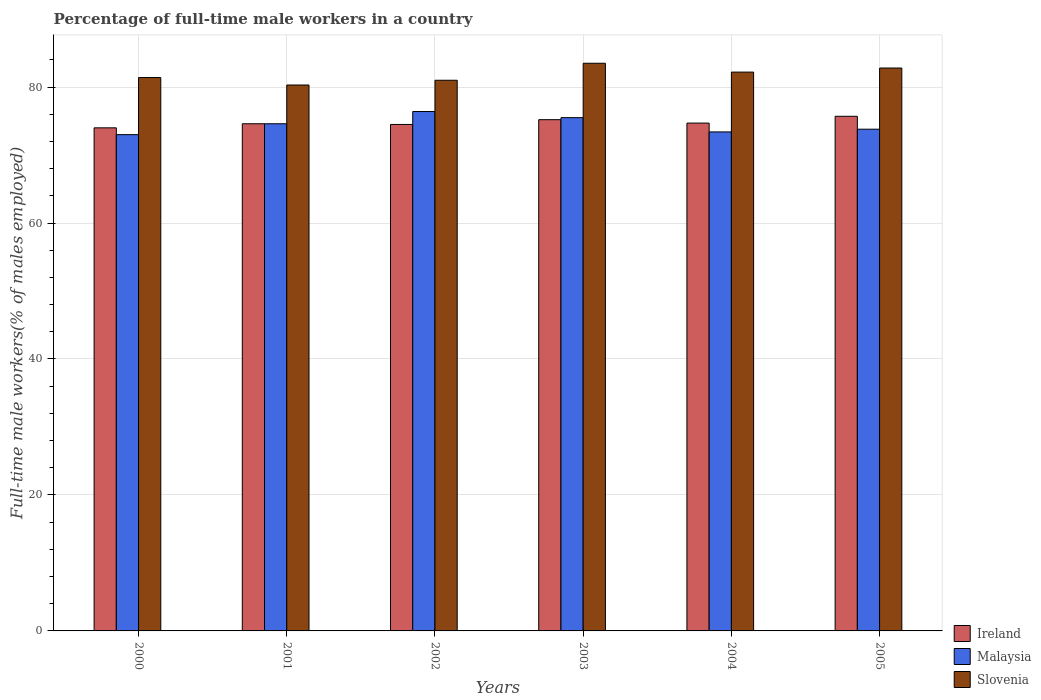How many different coloured bars are there?
Provide a short and direct response. 3. Are the number of bars per tick equal to the number of legend labels?
Your answer should be very brief. Yes. Are the number of bars on each tick of the X-axis equal?
Give a very brief answer. Yes. How many bars are there on the 3rd tick from the right?
Provide a succinct answer. 3. What is the percentage of full-time male workers in Malaysia in 2003?
Offer a very short reply. 75.5. Across all years, what is the maximum percentage of full-time male workers in Slovenia?
Provide a short and direct response. 83.5. In which year was the percentage of full-time male workers in Ireland minimum?
Provide a short and direct response. 2000. What is the total percentage of full-time male workers in Malaysia in the graph?
Your response must be concise. 446.7. What is the difference between the percentage of full-time male workers in Malaysia in 2002 and that in 2004?
Your response must be concise. 3. What is the difference between the percentage of full-time male workers in Ireland in 2001 and the percentage of full-time male workers in Slovenia in 2004?
Provide a short and direct response. -7.6. What is the average percentage of full-time male workers in Ireland per year?
Offer a terse response. 74.78. In the year 2002, what is the difference between the percentage of full-time male workers in Malaysia and percentage of full-time male workers in Slovenia?
Your answer should be very brief. -4.6. What is the ratio of the percentage of full-time male workers in Ireland in 2002 to that in 2004?
Ensure brevity in your answer.  1. What is the difference between the highest and the second highest percentage of full-time male workers in Malaysia?
Offer a terse response. 0.9. What is the difference between the highest and the lowest percentage of full-time male workers in Slovenia?
Offer a very short reply. 3.2. In how many years, is the percentage of full-time male workers in Ireland greater than the average percentage of full-time male workers in Ireland taken over all years?
Provide a short and direct response. 2. What does the 2nd bar from the left in 2001 represents?
Provide a succinct answer. Malaysia. What does the 2nd bar from the right in 2002 represents?
Your response must be concise. Malaysia. Is it the case that in every year, the sum of the percentage of full-time male workers in Ireland and percentage of full-time male workers in Slovenia is greater than the percentage of full-time male workers in Malaysia?
Your response must be concise. Yes. How many bars are there?
Offer a very short reply. 18. Are all the bars in the graph horizontal?
Your response must be concise. No. How many years are there in the graph?
Provide a short and direct response. 6. What is the difference between two consecutive major ticks on the Y-axis?
Keep it short and to the point. 20. Does the graph contain any zero values?
Keep it short and to the point. No. Does the graph contain grids?
Make the answer very short. Yes. How are the legend labels stacked?
Provide a succinct answer. Vertical. What is the title of the graph?
Ensure brevity in your answer.  Percentage of full-time male workers in a country. Does "Germany" appear as one of the legend labels in the graph?
Provide a short and direct response. No. What is the label or title of the Y-axis?
Offer a very short reply. Full-time male workers(% of males employed). What is the Full-time male workers(% of males employed) of Ireland in 2000?
Give a very brief answer. 74. What is the Full-time male workers(% of males employed) in Slovenia in 2000?
Provide a short and direct response. 81.4. What is the Full-time male workers(% of males employed) of Ireland in 2001?
Your answer should be very brief. 74.6. What is the Full-time male workers(% of males employed) of Malaysia in 2001?
Give a very brief answer. 74.6. What is the Full-time male workers(% of males employed) in Slovenia in 2001?
Your response must be concise. 80.3. What is the Full-time male workers(% of males employed) in Ireland in 2002?
Your answer should be very brief. 74.5. What is the Full-time male workers(% of males employed) in Malaysia in 2002?
Give a very brief answer. 76.4. What is the Full-time male workers(% of males employed) of Ireland in 2003?
Offer a terse response. 75.2. What is the Full-time male workers(% of males employed) of Malaysia in 2003?
Provide a short and direct response. 75.5. What is the Full-time male workers(% of males employed) in Slovenia in 2003?
Offer a very short reply. 83.5. What is the Full-time male workers(% of males employed) of Ireland in 2004?
Give a very brief answer. 74.7. What is the Full-time male workers(% of males employed) in Malaysia in 2004?
Your response must be concise. 73.4. What is the Full-time male workers(% of males employed) in Slovenia in 2004?
Provide a short and direct response. 82.2. What is the Full-time male workers(% of males employed) of Ireland in 2005?
Keep it short and to the point. 75.7. What is the Full-time male workers(% of males employed) in Malaysia in 2005?
Offer a very short reply. 73.8. What is the Full-time male workers(% of males employed) of Slovenia in 2005?
Your answer should be very brief. 82.8. Across all years, what is the maximum Full-time male workers(% of males employed) of Ireland?
Your answer should be very brief. 75.7. Across all years, what is the maximum Full-time male workers(% of males employed) in Malaysia?
Offer a terse response. 76.4. Across all years, what is the maximum Full-time male workers(% of males employed) of Slovenia?
Offer a terse response. 83.5. Across all years, what is the minimum Full-time male workers(% of males employed) of Slovenia?
Offer a very short reply. 80.3. What is the total Full-time male workers(% of males employed) in Ireland in the graph?
Keep it short and to the point. 448.7. What is the total Full-time male workers(% of males employed) in Malaysia in the graph?
Your answer should be very brief. 446.7. What is the total Full-time male workers(% of males employed) in Slovenia in the graph?
Make the answer very short. 491.2. What is the difference between the Full-time male workers(% of males employed) in Ireland in 2000 and that in 2002?
Keep it short and to the point. -0.5. What is the difference between the Full-time male workers(% of males employed) in Slovenia in 2000 and that in 2002?
Your answer should be compact. 0.4. What is the difference between the Full-time male workers(% of males employed) in Ireland in 2000 and that in 2003?
Give a very brief answer. -1.2. What is the difference between the Full-time male workers(% of males employed) in Malaysia in 2000 and that in 2003?
Provide a short and direct response. -2.5. What is the difference between the Full-time male workers(% of males employed) of Slovenia in 2000 and that in 2003?
Your answer should be very brief. -2.1. What is the difference between the Full-time male workers(% of males employed) of Slovenia in 2000 and that in 2004?
Your response must be concise. -0.8. What is the difference between the Full-time male workers(% of males employed) in Slovenia in 2000 and that in 2005?
Offer a terse response. -1.4. What is the difference between the Full-time male workers(% of males employed) of Ireland in 2001 and that in 2002?
Your answer should be very brief. 0.1. What is the difference between the Full-time male workers(% of males employed) in Malaysia in 2001 and that in 2003?
Your answer should be very brief. -0.9. What is the difference between the Full-time male workers(% of males employed) in Slovenia in 2001 and that in 2003?
Offer a terse response. -3.2. What is the difference between the Full-time male workers(% of males employed) of Ireland in 2001 and that in 2004?
Make the answer very short. -0.1. What is the difference between the Full-time male workers(% of males employed) in Malaysia in 2001 and that in 2004?
Offer a terse response. 1.2. What is the difference between the Full-time male workers(% of males employed) in Slovenia in 2001 and that in 2004?
Offer a terse response. -1.9. What is the difference between the Full-time male workers(% of males employed) of Slovenia in 2001 and that in 2005?
Make the answer very short. -2.5. What is the difference between the Full-time male workers(% of males employed) of Malaysia in 2002 and that in 2003?
Ensure brevity in your answer.  0.9. What is the difference between the Full-time male workers(% of males employed) in Slovenia in 2002 and that in 2003?
Offer a terse response. -2.5. What is the difference between the Full-time male workers(% of males employed) in Ireland in 2002 and that in 2004?
Provide a short and direct response. -0.2. What is the difference between the Full-time male workers(% of males employed) in Malaysia in 2002 and that in 2004?
Your response must be concise. 3. What is the difference between the Full-time male workers(% of males employed) in Slovenia in 2002 and that in 2004?
Ensure brevity in your answer.  -1.2. What is the difference between the Full-time male workers(% of males employed) in Ireland in 2003 and that in 2005?
Your answer should be very brief. -0.5. What is the difference between the Full-time male workers(% of males employed) of Slovenia in 2003 and that in 2005?
Your response must be concise. 0.7. What is the difference between the Full-time male workers(% of males employed) of Ireland in 2004 and that in 2005?
Your response must be concise. -1. What is the difference between the Full-time male workers(% of males employed) in Malaysia in 2004 and that in 2005?
Your answer should be very brief. -0.4. What is the difference between the Full-time male workers(% of males employed) of Slovenia in 2004 and that in 2005?
Offer a terse response. -0.6. What is the difference between the Full-time male workers(% of males employed) in Malaysia in 2000 and the Full-time male workers(% of males employed) in Slovenia in 2002?
Provide a succinct answer. -8. What is the difference between the Full-time male workers(% of males employed) in Ireland in 2000 and the Full-time male workers(% of males employed) in Slovenia in 2003?
Offer a terse response. -9.5. What is the difference between the Full-time male workers(% of males employed) of Ireland in 2000 and the Full-time male workers(% of males employed) of Slovenia in 2004?
Your answer should be compact. -8.2. What is the difference between the Full-time male workers(% of males employed) of Ireland in 2000 and the Full-time male workers(% of males employed) of Malaysia in 2005?
Keep it short and to the point. 0.2. What is the difference between the Full-time male workers(% of males employed) of Ireland in 2000 and the Full-time male workers(% of males employed) of Slovenia in 2005?
Your answer should be compact. -8.8. What is the difference between the Full-time male workers(% of males employed) in Malaysia in 2000 and the Full-time male workers(% of males employed) in Slovenia in 2005?
Your response must be concise. -9.8. What is the difference between the Full-time male workers(% of males employed) in Ireland in 2001 and the Full-time male workers(% of males employed) in Slovenia in 2002?
Provide a succinct answer. -6.4. What is the difference between the Full-time male workers(% of males employed) of Ireland in 2001 and the Full-time male workers(% of males employed) of Malaysia in 2003?
Your answer should be compact. -0.9. What is the difference between the Full-time male workers(% of males employed) in Malaysia in 2001 and the Full-time male workers(% of males employed) in Slovenia in 2004?
Your answer should be compact. -7.6. What is the difference between the Full-time male workers(% of males employed) in Ireland in 2001 and the Full-time male workers(% of males employed) in Malaysia in 2005?
Offer a very short reply. 0.8. What is the difference between the Full-time male workers(% of males employed) of Malaysia in 2001 and the Full-time male workers(% of males employed) of Slovenia in 2005?
Your answer should be compact. -8.2. What is the difference between the Full-time male workers(% of males employed) of Ireland in 2002 and the Full-time male workers(% of males employed) of Malaysia in 2003?
Give a very brief answer. -1. What is the difference between the Full-time male workers(% of males employed) of Ireland in 2002 and the Full-time male workers(% of males employed) of Malaysia in 2004?
Offer a terse response. 1.1. What is the difference between the Full-time male workers(% of males employed) of Malaysia in 2002 and the Full-time male workers(% of males employed) of Slovenia in 2004?
Keep it short and to the point. -5.8. What is the difference between the Full-time male workers(% of males employed) in Malaysia in 2002 and the Full-time male workers(% of males employed) in Slovenia in 2005?
Offer a very short reply. -6.4. What is the difference between the Full-time male workers(% of males employed) in Ireland in 2003 and the Full-time male workers(% of males employed) in Malaysia in 2005?
Ensure brevity in your answer.  1.4. What is the difference between the Full-time male workers(% of males employed) of Ireland in 2003 and the Full-time male workers(% of males employed) of Slovenia in 2005?
Your response must be concise. -7.6. What is the difference between the Full-time male workers(% of males employed) of Ireland in 2004 and the Full-time male workers(% of males employed) of Malaysia in 2005?
Keep it short and to the point. 0.9. What is the difference between the Full-time male workers(% of males employed) of Ireland in 2004 and the Full-time male workers(% of males employed) of Slovenia in 2005?
Provide a short and direct response. -8.1. What is the difference between the Full-time male workers(% of males employed) of Malaysia in 2004 and the Full-time male workers(% of males employed) of Slovenia in 2005?
Provide a succinct answer. -9.4. What is the average Full-time male workers(% of males employed) of Ireland per year?
Provide a succinct answer. 74.78. What is the average Full-time male workers(% of males employed) of Malaysia per year?
Provide a short and direct response. 74.45. What is the average Full-time male workers(% of males employed) of Slovenia per year?
Make the answer very short. 81.87. In the year 2001, what is the difference between the Full-time male workers(% of males employed) of Ireland and Full-time male workers(% of males employed) of Slovenia?
Keep it short and to the point. -5.7. In the year 2003, what is the difference between the Full-time male workers(% of males employed) in Ireland and Full-time male workers(% of males employed) in Malaysia?
Offer a very short reply. -0.3. In the year 2003, what is the difference between the Full-time male workers(% of males employed) in Malaysia and Full-time male workers(% of males employed) in Slovenia?
Provide a short and direct response. -8. In the year 2004, what is the difference between the Full-time male workers(% of males employed) of Ireland and Full-time male workers(% of males employed) of Malaysia?
Provide a short and direct response. 1.3. In the year 2005, what is the difference between the Full-time male workers(% of males employed) in Malaysia and Full-time male workers(% of males employed) in Slovenia?
Offer a terse response. -9. What is the ratio of the Full-time male workers(% of males employed) of Ireland in 2000 to that in 2001?
Offer a very short reply. 0.99. What is the ratio of the Full-time male workers(% of males employed) of Malaysia in 2000 to that in 2001?
Your answer should be compact. 0.98. What is the ratio of the Full-time male workers(% of males employed) of Slovenia in 2000 to that in 2001?
Give a very brief answer. 1.01. What is the ratio of the Full-time male workers(% of males employed) in Ireland in 2000 to that in 2002?
Your answer should be very brief. 0.99. What is the ratio of the Full-time male workers(% of males employed) of Malaysia in 2000 to that in 2002?
Your answer should be very brief. 0.96. What is the ratio of the Full-time male workers(% of males employed) in Malaysia in 2000 to that in 2003?
Your response must be concise. 0.97. What is the ratio of the Full-time male workers(% of males employed) of Slovenia in 2000 to that in 2003?
Provide a succinct answer. 0.97. What is the ratio of the Full-time male workers(% of males employed) in Ireland in 2000 to that in 2004?
Ensure brevity in your answer.  0.99. What is the ratio of the Full-time male workers(% of males employed) in Slovenia in 2000 to that in 2004?
Offer a terse response. 0.99. What is the ratio of the Full-time male workers(% of males employed) in Ireland in 2000 to that in 2005?
Give a very brief answer. 0.98. What is the ratio of the Full-time male workers(% of males employed) in Malaysia in 2000 to that in 2005?
Offer a terse response. 0.99. What is the ratio of the Full-time male workers(% of males employed) in Slovenia in 2000 to that in 2005?
Give a very brief answer. 0.98. What is the ratio of the Full-time male workers(% of males employed) in Malaysia in 2001 to that in 2002?
Offer a very short reply. 0.98. What is the ratio of the Full-time male workers(% of males employed) in Slovenia in 2001 to that in 2002?
Give a very brief answer. 0.99. What is the ratio of the Full-time male workers(% of males employed) in Slovenia in 2001 to that in 2003?
Your answer should be very brief. 0.96. What is the ratio of the Full-time male workers(% of males employed) in Malaysia in 2001 to that in 2004?
Your answer should be compact. 1.02. What is the ratio of the Full-time male workers(% of males employed) in Slovenia in 2001 to that in 2004?
Your response must be concise. 0.98. What is the ratio of the Full-time male workers(% of males employed) in Ireland in 2001 to that in 2005?
Give a very brief answer. 0.99. What is the ratio of the Full-time male workers(% of males employed) in Malaysia in 2001 to that in 2005?
Ensure brevity in your answer.  1.01. What is the ratio of the Full-time male workers(% of males employed) of Slovenia in 2001 to that in 2005?
Offer a very short reply. 0.97. What is the ratio of the Full-time male workers(% of males employed) of Malaysia in 2002 to that in 2003?
Your answer should be very brief. 1.01. What is the ratio of the Full-time male workers(% of males employed) of Slovenia in 2002 to that in 2003?
Provide a short and direct response. 0.97. What is the ratio of the Full-time male workers(% of males employed) in Ireland in 2002 to that in 2004?
Provide a short and direct response. 1. What is the ratio of the Full-time male workers(% of males employed) in Malaysia in 2002 to that in 2004?
Provide a short and direct response. 1.04. What is the ratio of the Full-time male workers(% of males employed) of Slovenia in 2002 to that in 2004?
Your answer should be very brief. 0.99. What is the ratio of the Full-time male workers(% of males employed) of Ireland in 2002 to that in 2005?
Provide a short and direct response. 0.98. What is the ratio of the Full-time male workers(% of males employed) of Malaysia in 2002 to that in 2005?
Give a very brief answer. 1.04. What is the ratio of the Full-time male workers(% of males employed) in Slovenia in 2002 to that in 2005?
Your answer should be very brief. 0.98. What is the ratio of the Full-time male workers(% of males employed) of Ireland in 2003 to that in 2004?
Ensure brevity in your answer.  1.01. What is the ratio of the Full-time male workers(% of males employed) in Malaysia in 2003 to that in 2004?
Offer a very short reply. 1.03. What is the ratio of the Full-time male workers(% of males employed) in Slovenia in 2003 to that in 2004?
Provide a succinct answer. 1.02. What is the ratio of the Full-time male workers(% of males employed) in Slovenia in 2003 to that in 2005?
Keep it short and to the point. 1.01. What is the ratio of the Full-time male workers(% of males employed) of Ireland in 2004 to that in 2005?
Your response must be concise. 0.99. What is the ratio of the Full-time male workers(% of males employed) in Slovenia in 2004 to that in 2005?
Make the answer very short. 0.99. What is the difference between the highest and the second highest Full-time male workers(% of males employed) in Malaysia?
Make the answer very short. 0.9. What is the difference between the highest and the lowest Full-time male workers(% of males employed) of Slovenia?
Your answer should be compact. 3.2. 